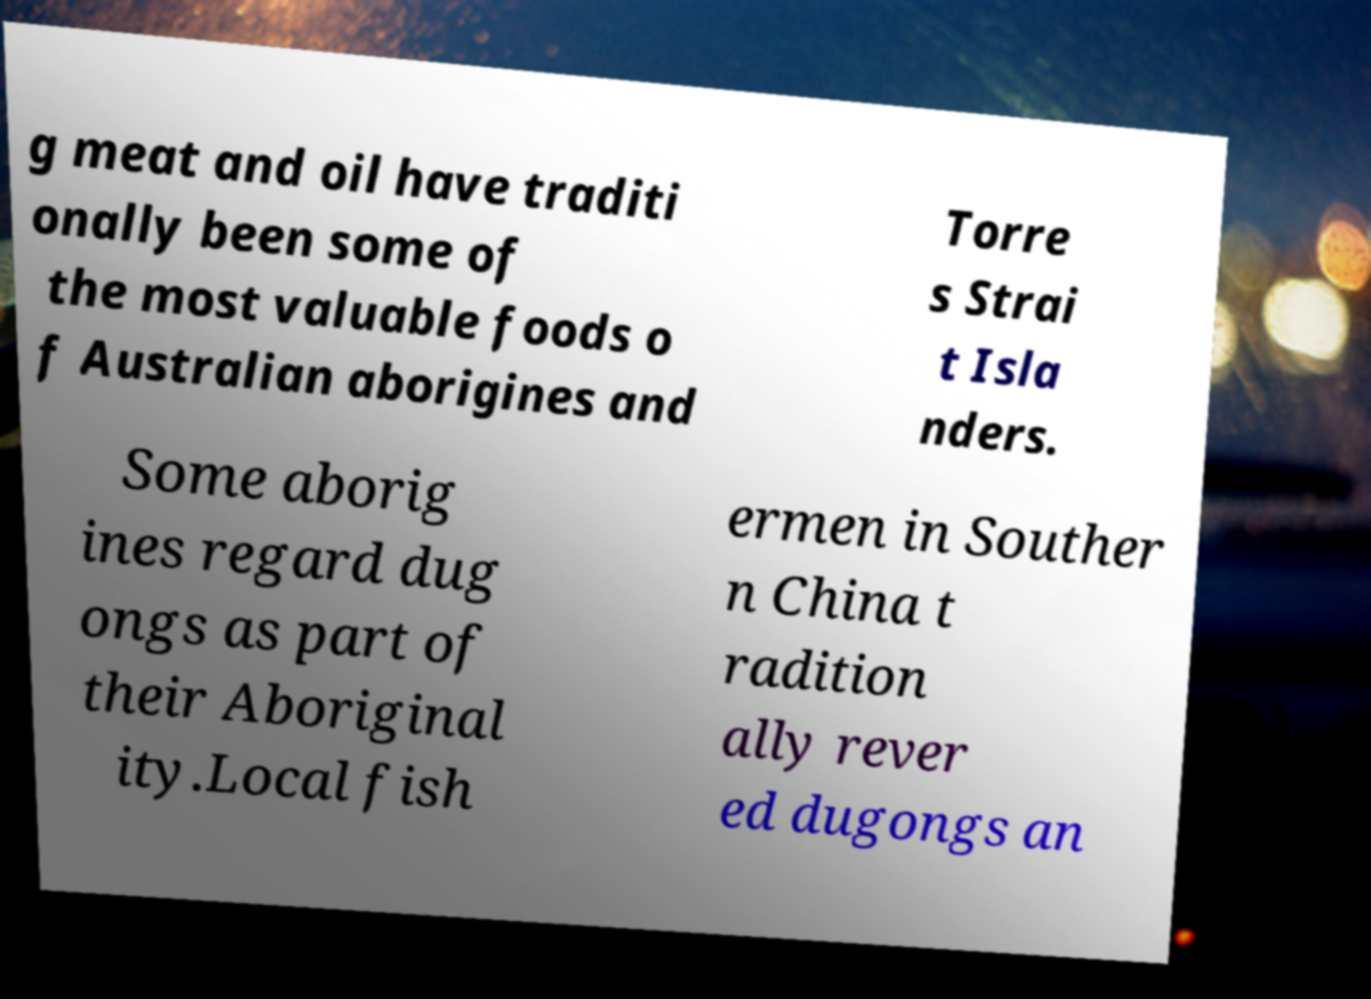For documentation purposes, I need the text within this image transcribed. Could you provide that? g meat and oil have traditi onally been some of the most valuable foods o f Australian aborigines and Torre s Strai t Isla nders. Some aborig ines regard dug ongs as part of their Aboriginal ity.Local fish ermen in Souther n China t radition ally rever ed dugongs an 